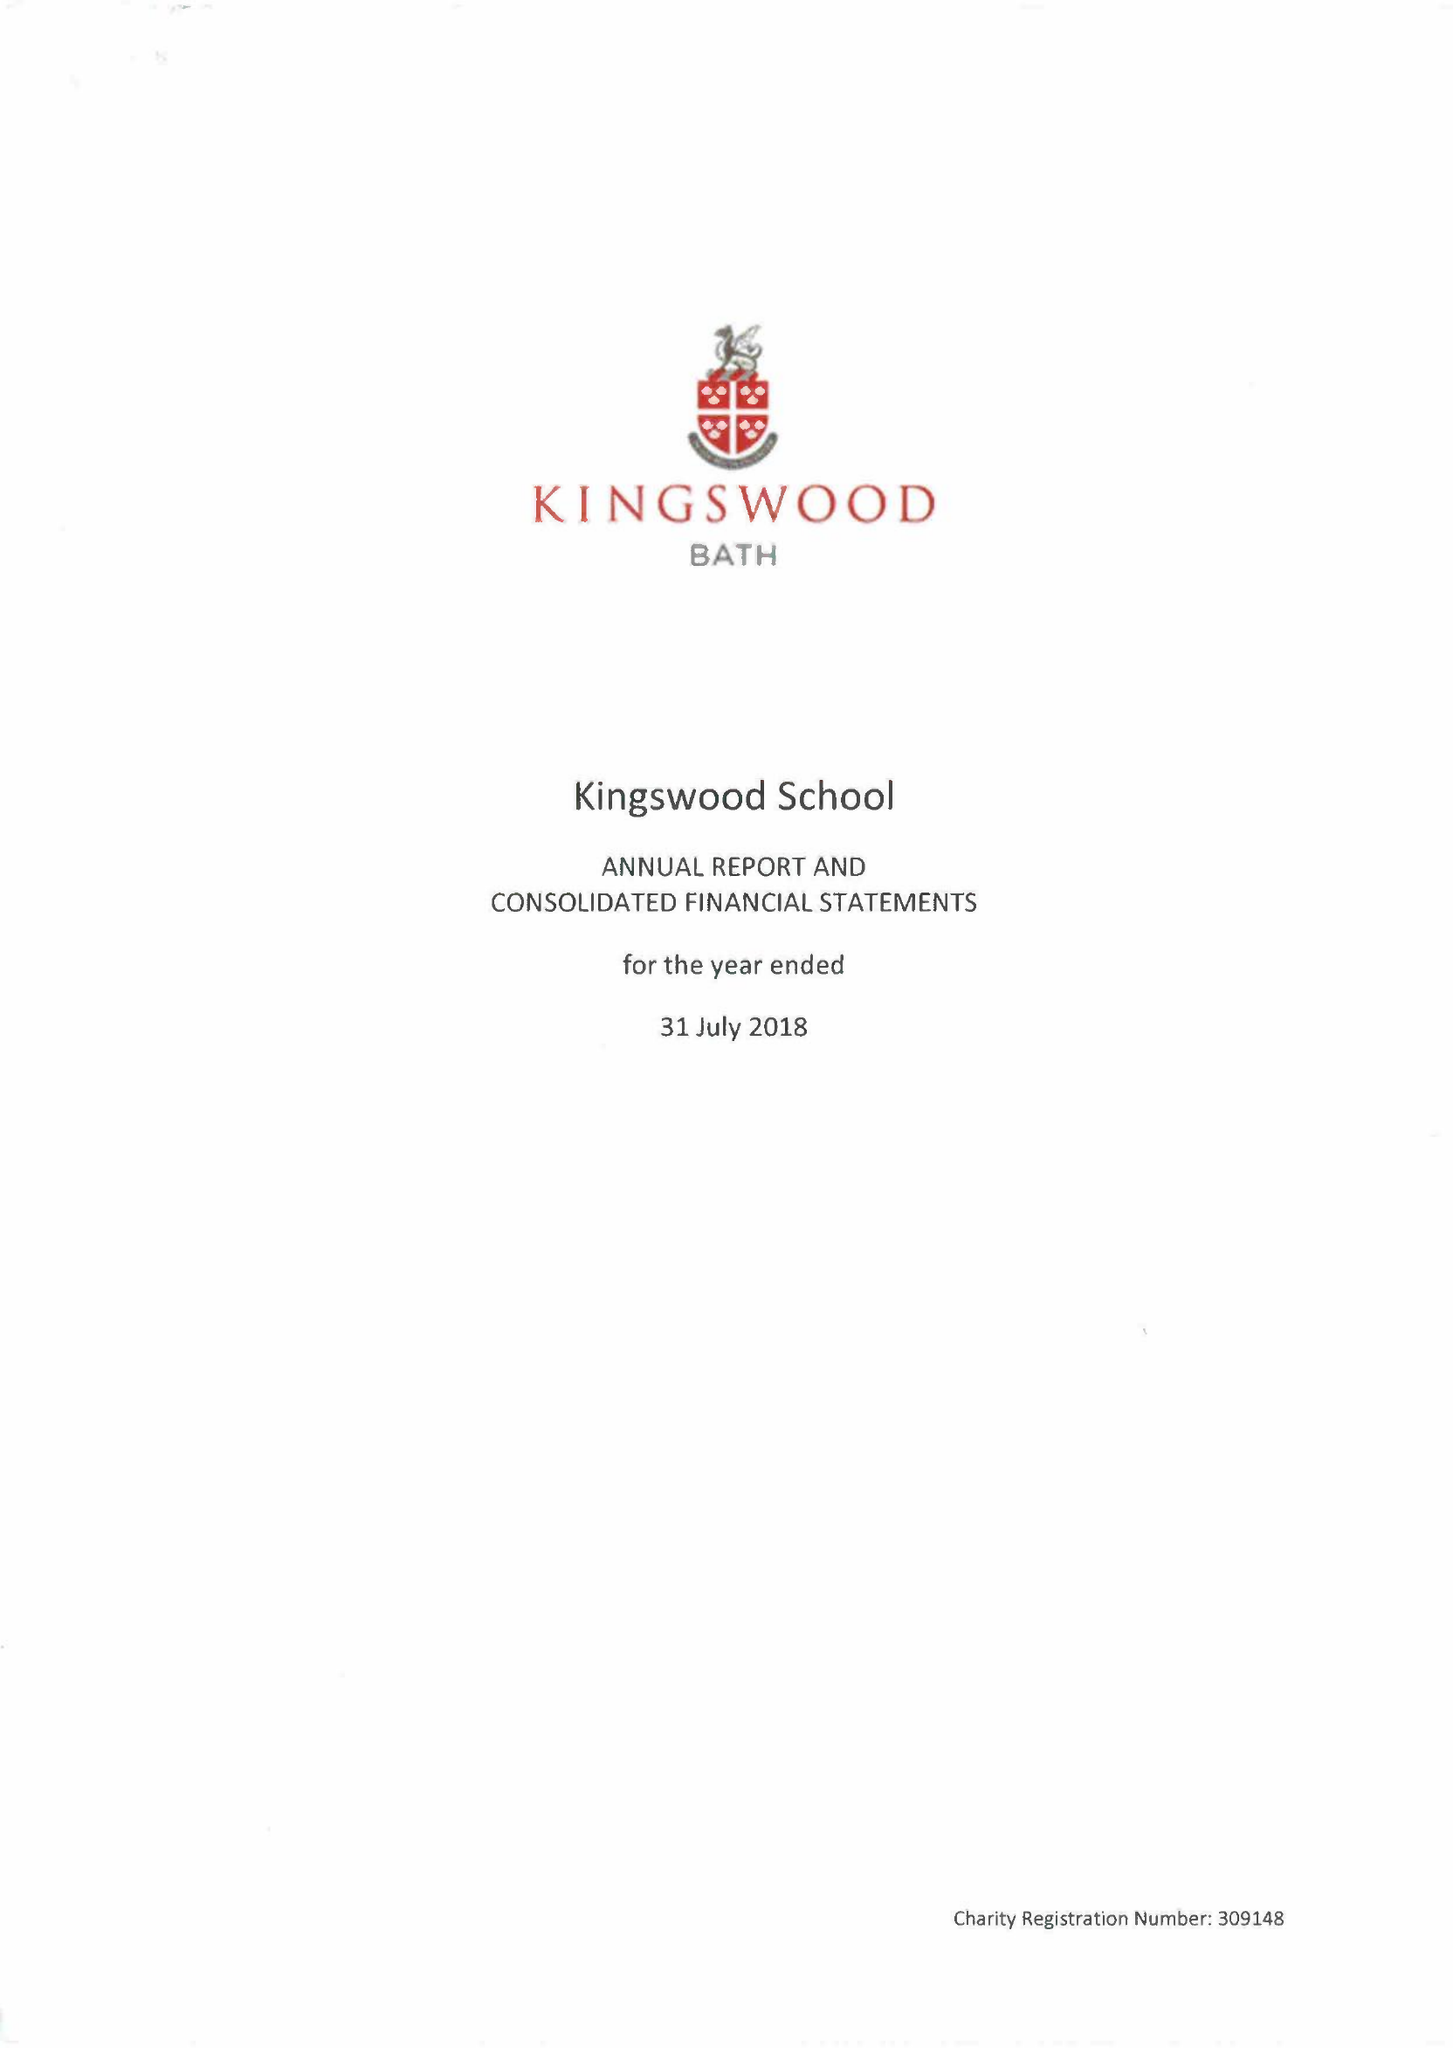What is the value for the report_date?
Answer the question using a single word or phrase. 2018-07-31 